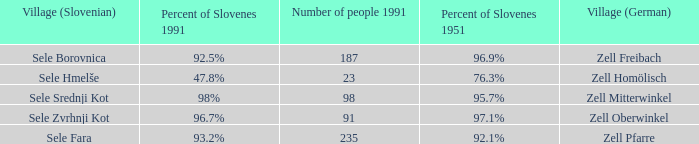Provide me with the names of all the villages (German) that has 76.3% of Slovenes in 1951. Zell Homölisch. 